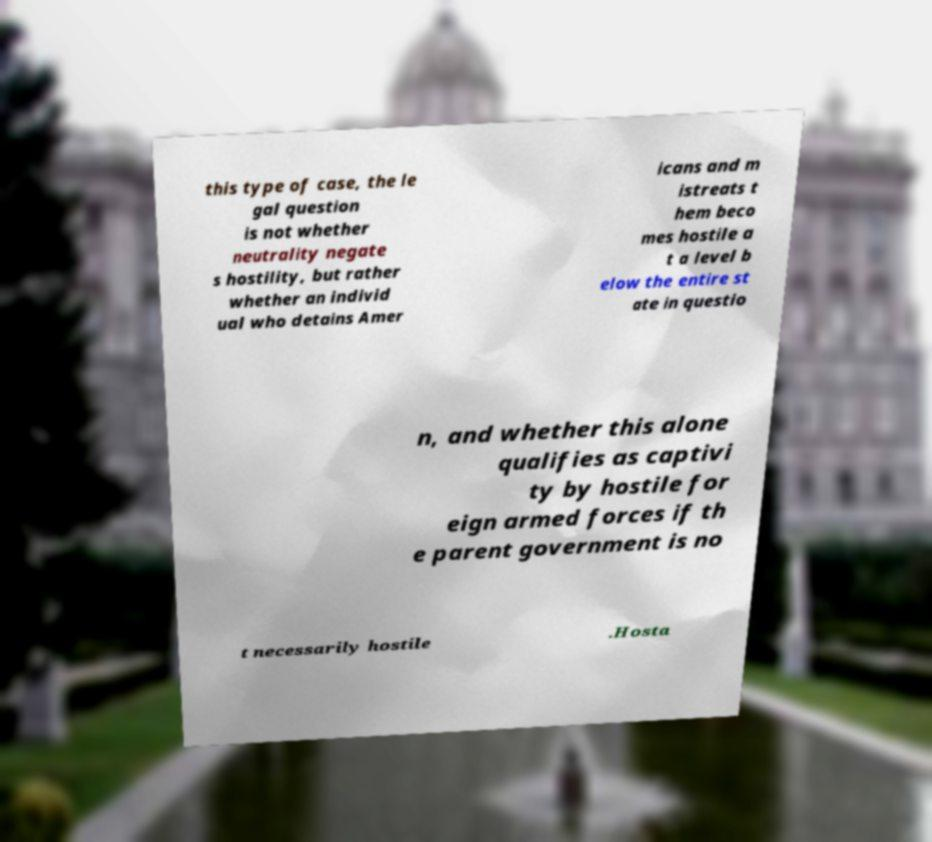Could you extract and type out the text from this image? this type of case, the le gal question is not whether neutrality negate s hostility, but rather whether an individ ual who detains Amer icans and m istreats t hem beco mes hostile a t a level b elow the entire st ate in questio n, and whether this alone qualifies as captivi ty by hostile for eign armed forces if th e parent government is no t necessarily hostile .Hosta 